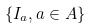Convert formula to latex. <formula><loc_0><loc_0><loc_500><loc_500>\{ I _ { a } , a \in A \}</formula> 